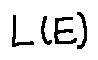<formula> <loc_0><loc_0><loc_500><loc_500>L ( E )</formula> 